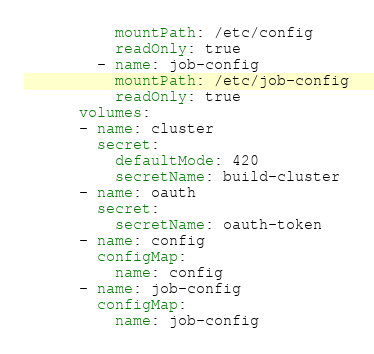Convert code to text. <code><loc_0><loc_0><loc_500><loc_500><_YAML_>          mountPath: /etc/config
          readOnly: true
        - name: job-config
          mountPath: /etc/job-config
          readOnly: true
      volumes:
      - name: cluster
        secret:
          defaultMode: 420
          secretName: build-cluster
      - name: oauth
        secret:
          secretName: oauth-token
      - name: config
        configMap:
          name: config
      - name: job-config
        configMap:
          name: job-config
</code> 